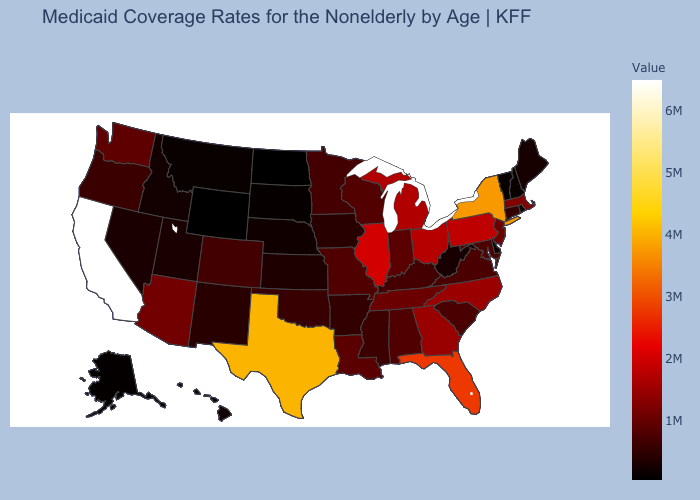Does the map have missing data?
Give a very brief answer. No. Which states have the highest value in the USA?
Quick response, please. California. Among the states that border Delaware , does Maryland have the lowest value?
Short answer required. Yes. 